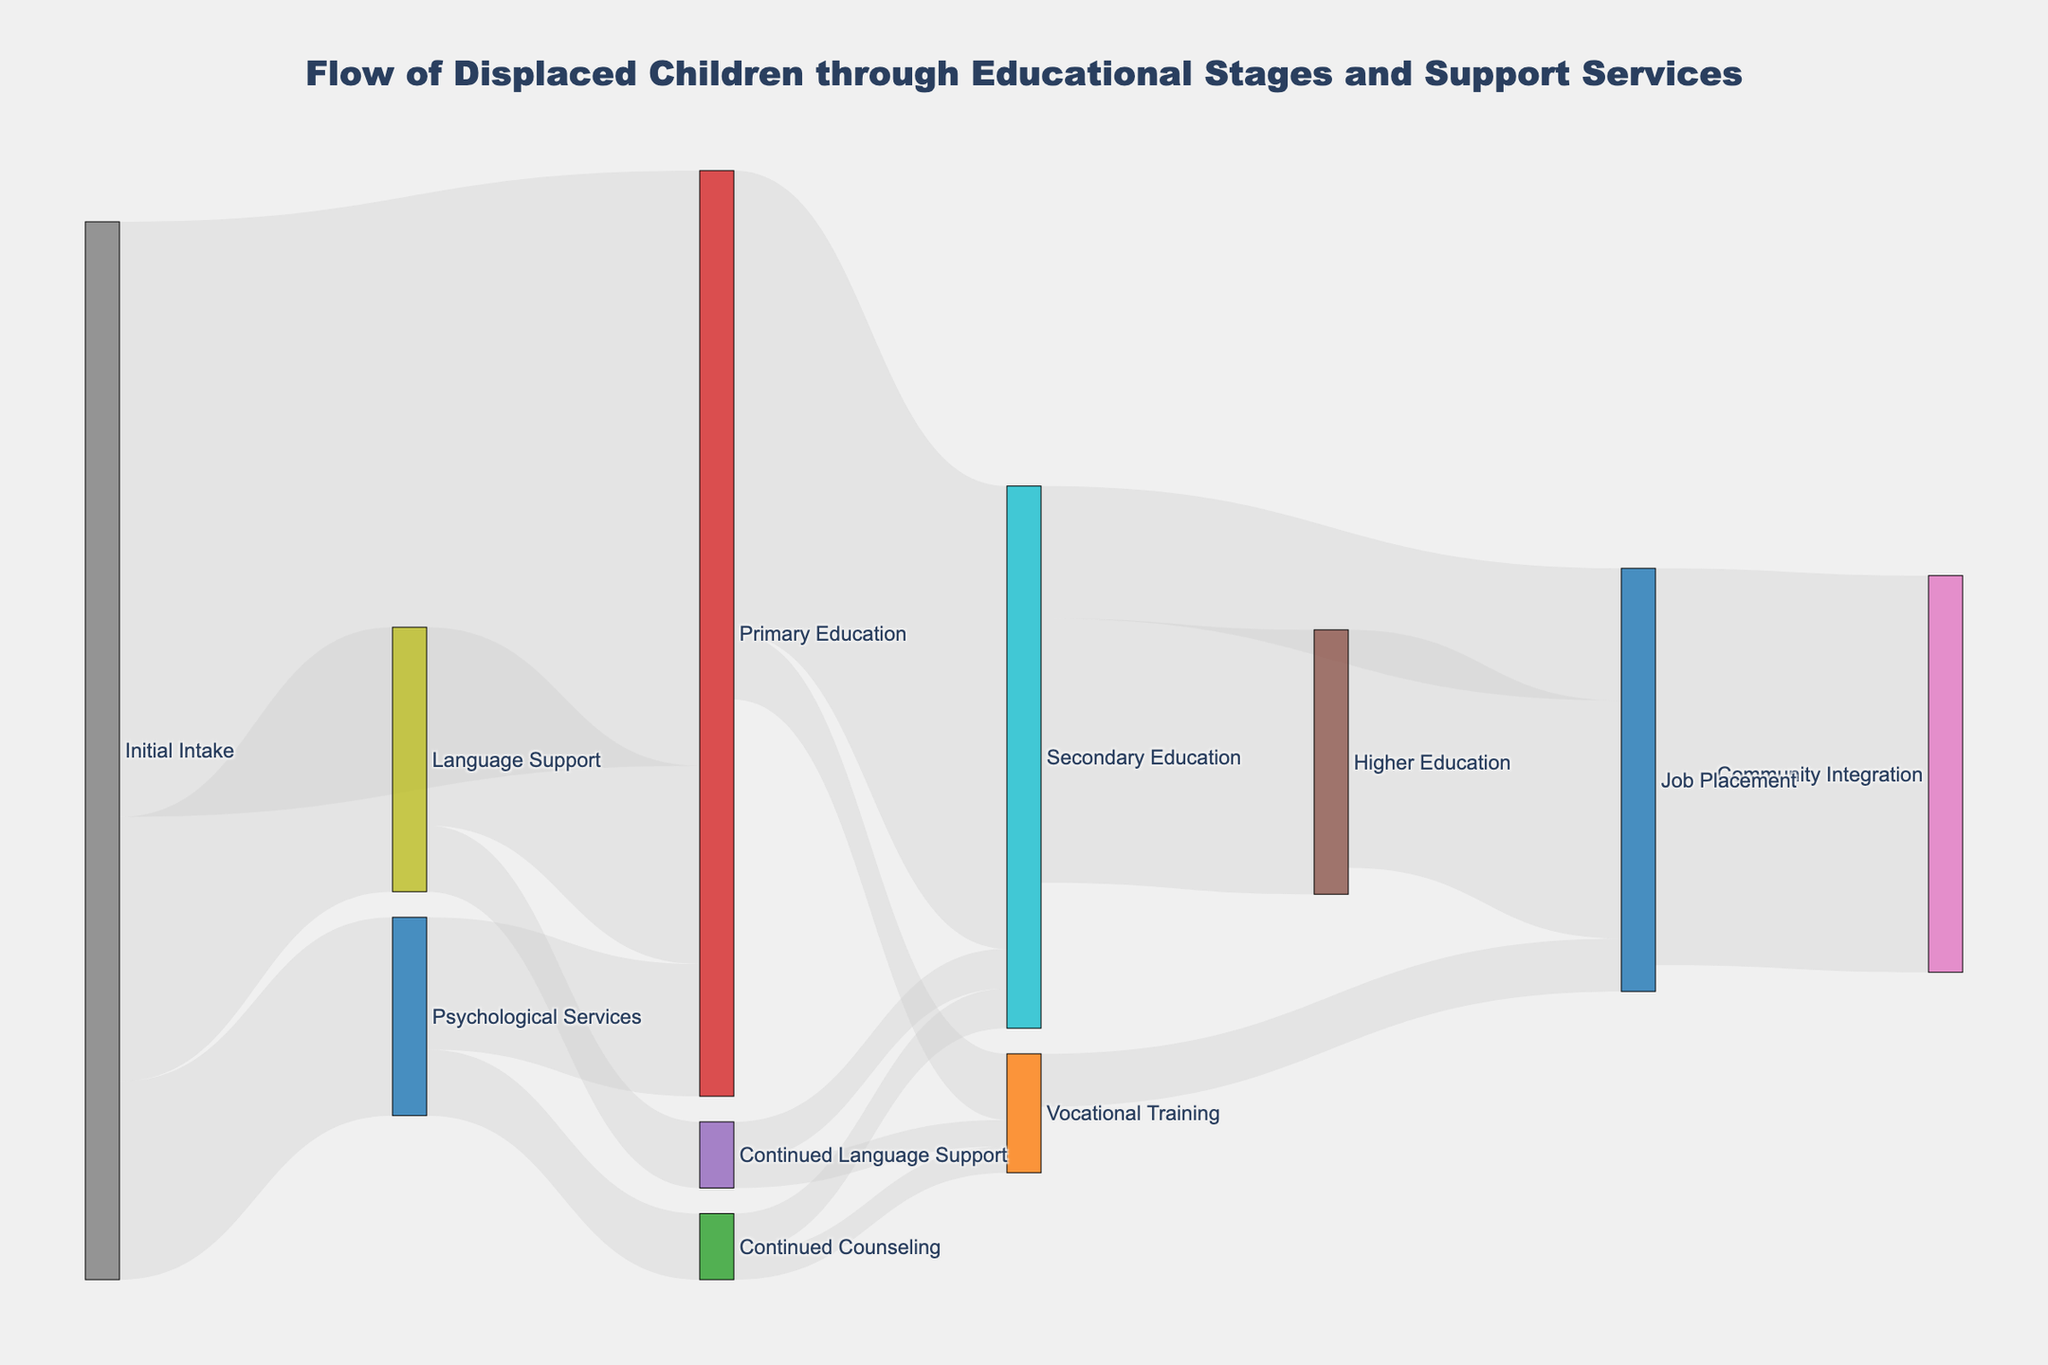what is the total number of children who moved from initial intake to primary education? Look for the link between "Initial Intake" and "Primary Education" in the Sankey diagram and find the value.
Answer: 450 How many children received psychological services initially? Look for the link between "Initial Intake" and "Psychological Services" and note the value.
Answer: 150 What is the sum of children moving from secondary education to higher education and job placement? Find the links from "Secondary Education" to "Higher Education" and "Job Placement", and sum their values (200 + 100).
Answer: 300 Which path had more children, from language support to primary education or from psychological services to primary education? Compare the values for "Language Support" to "Primary Education" (150) and "Psychological Services" to "Primary Education" (100).
Answer: Language Support to Primary Education How many total children entered vocational training? Sum the children who moved to "Vocational Training" from all sources: Primary Education (50), Continued Language Support (20), and Continued Counseling (20). This gives 50 + 20 + 20.
Answer: 90 From the children who started with primary education, how many moved to secondary education? Check the value of the link from "Primary Education" to "Secondary Education".
Answer: 350 Compare the number of children who went from primary to secondary education versus those who went from primary to vocational training. Find the values for "Primary Education" to "Secondary Education" (350) and "Primary Education" to "Vocational Training" (50), and compare them.
Answer: Primary to Secondary Education What is the number of children who ended up with job placement coming from both vocational training and higher education? Add the values from "Vocational Training" to "Job Placement" (40) and "Higher Education" to "Job Placement" (180).
Answer: 220 Between continued counseling and continued language support, which service had more children progressing to vocational training? Compare the values for "Continued Counseling" to "Vocational Training" (20) and "Continued Language Support" to "Vocational Training" (20).
Answer: They are equal How many children entered community integration after job placement? Check the value for the link "Job Placement" to "Community Integration".
Answer: 300 